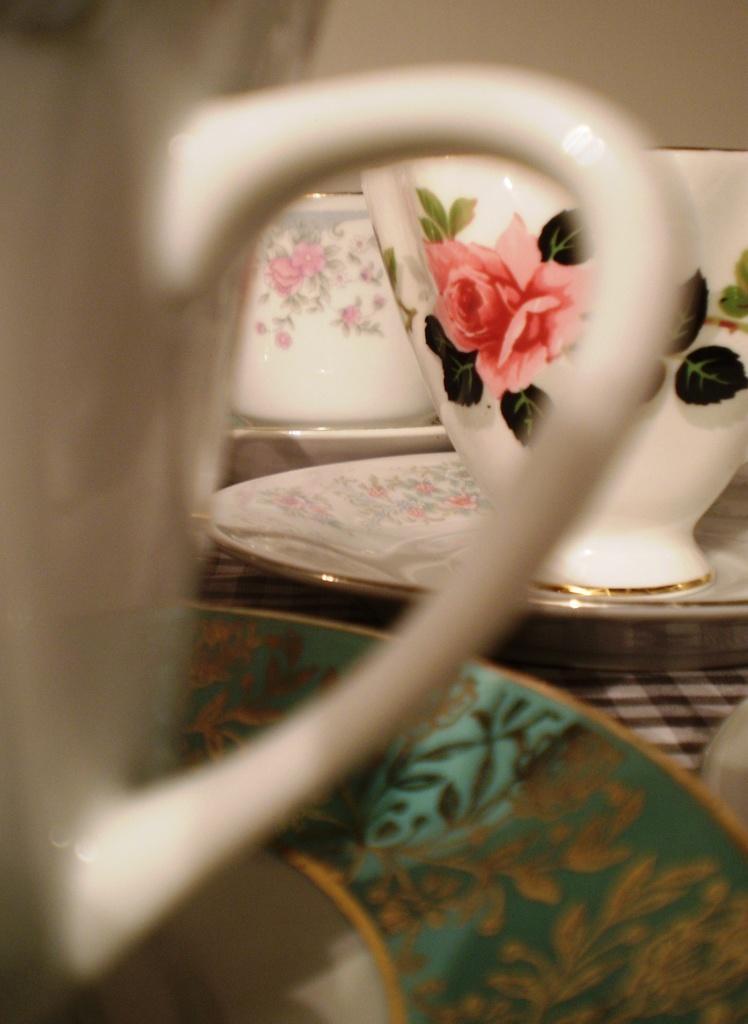Describe this image in one or two sentences. In this image we can see the cups and saucers. There is some painting on the cups and saucers. There is a cloth below the saucer. 